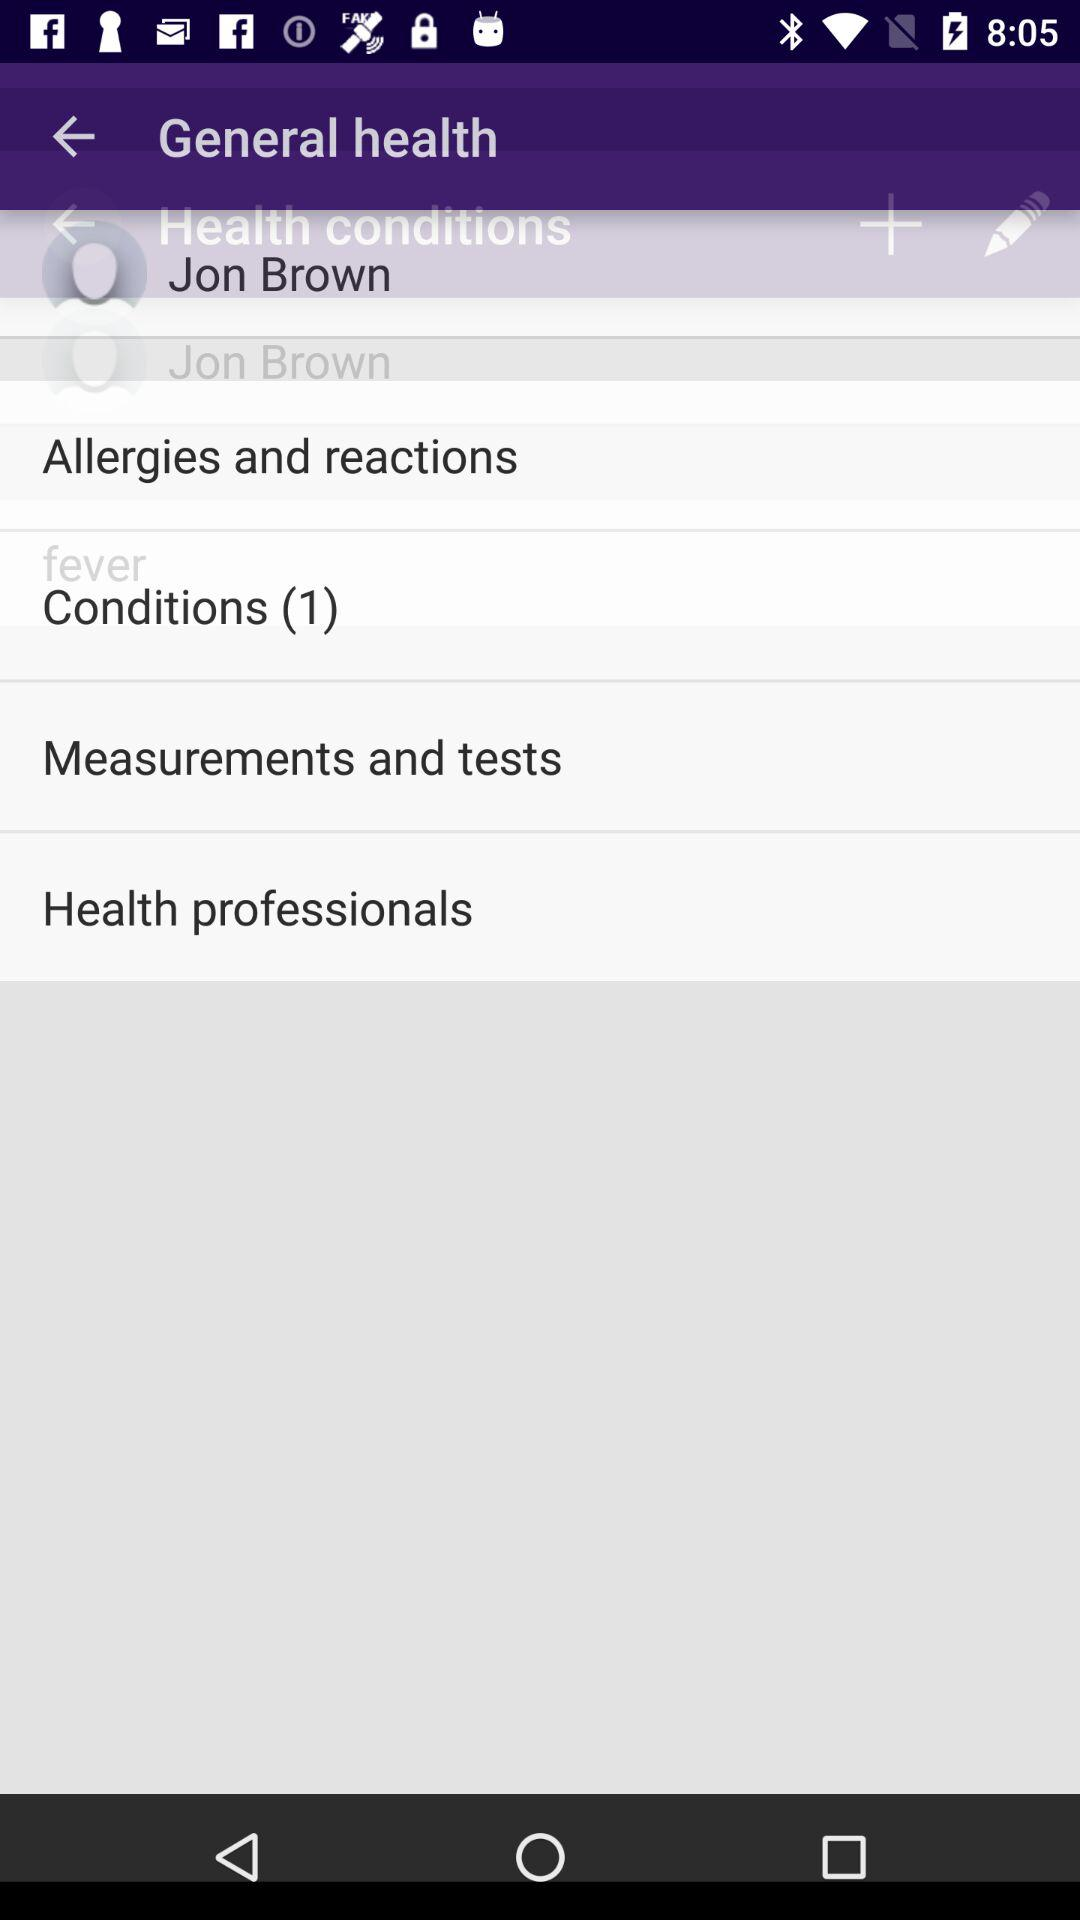What is the user name? The user name is Jon Brown. 